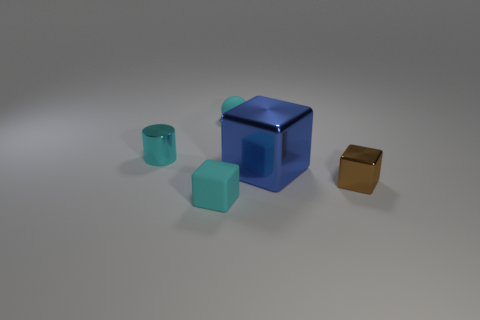Add 2 blue objects. How many objects exist? 7 Subtract all large metal cubes. How many cubes are left? 2 Subtract all cylinders. How many objects are left? 4 Subtract all cyan blocks. How many blocks are left? 2 Subtract 1 cubes. How many cubes are left? 2 Add 5 small cyan matte spheres. How many small cyan matte spheres exist? 6 Subtract 1 cyan spheres. How many objects are left? 4 Subtract all gray cylinders. Subtract all green spheres. How many cylinders are left? 1 Subtract all yellow cubes. How many purple balls are left? 0 Subtract all large blue shiny cubes. Subtract all large objects. How many objects are left? 3 